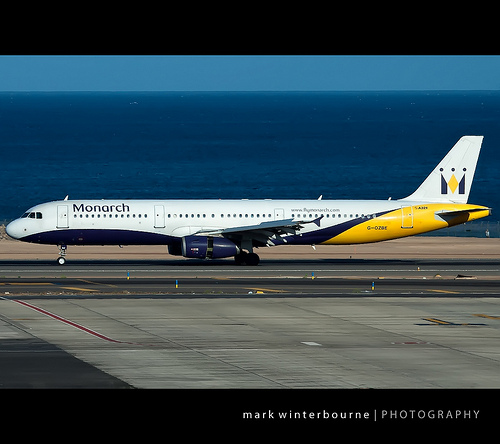Can you describe the overall color scheme of the plane? The plane's color scheme consists of a white upper section with blue and yellow accents. The tail features a prominent yellow portion with a white background and a logo. The bottom section of the plane is dark blue. What airline is represented by the plane in the image? The plane belongs to the airline 'Monarch,' as indicated by the text 'Monarch' written on the body of the aircraft. If this plane were a character in a story, how might you envision its adventures? Imagine this plane, affectionately named 'Sky Monarch,' as an adventurous character in a children's story. Sky Monarch embarks on journeys across the globe, flying through different weather conditions, visiting fascinating destinations, and forming friendships with other aircraft. Along the way, Sky Monarch helps transport important cargo and passengers, overcoming challenges such as storms and technical issues with the help of its trusted ground crew and onboard systems. The story would inspire young readers with themes of exploration, courage, and teamwork. 